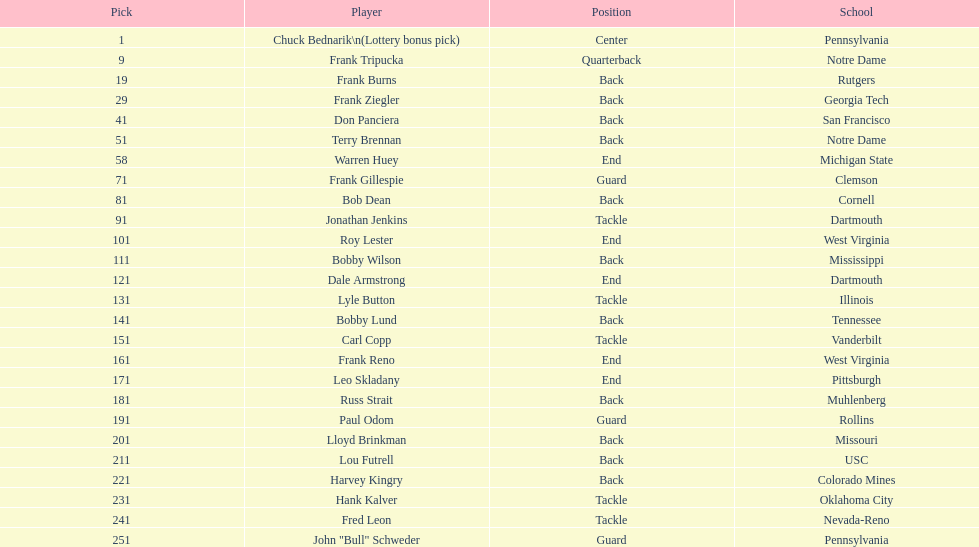Was chuck bednarik or frank tripucka the first draft pick? Chuck Bednarik. 